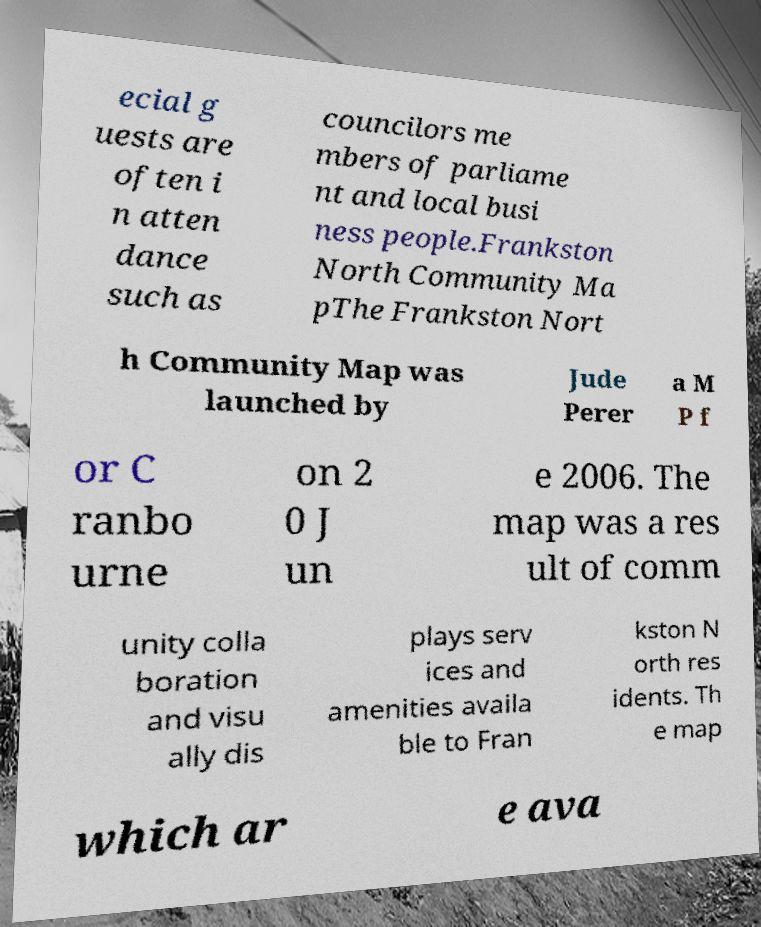What messages or text are displayed in this image? I need them in a readable, typed format. ecial g uests are often i n atten dance such as councilors me mbers of parliame nt and local busi ness people.Frankston North Community Ma pThe Frankston Nort h Community Map was launched by Jude Perer a M P f or C ranbo urne on 2 0 J un e 2006. The map was a res ult of comm unity colla boration and visu ally dis plays serv ices and amenities availa ble to Fran kston N orth res idents. Th e map which ar e ava 